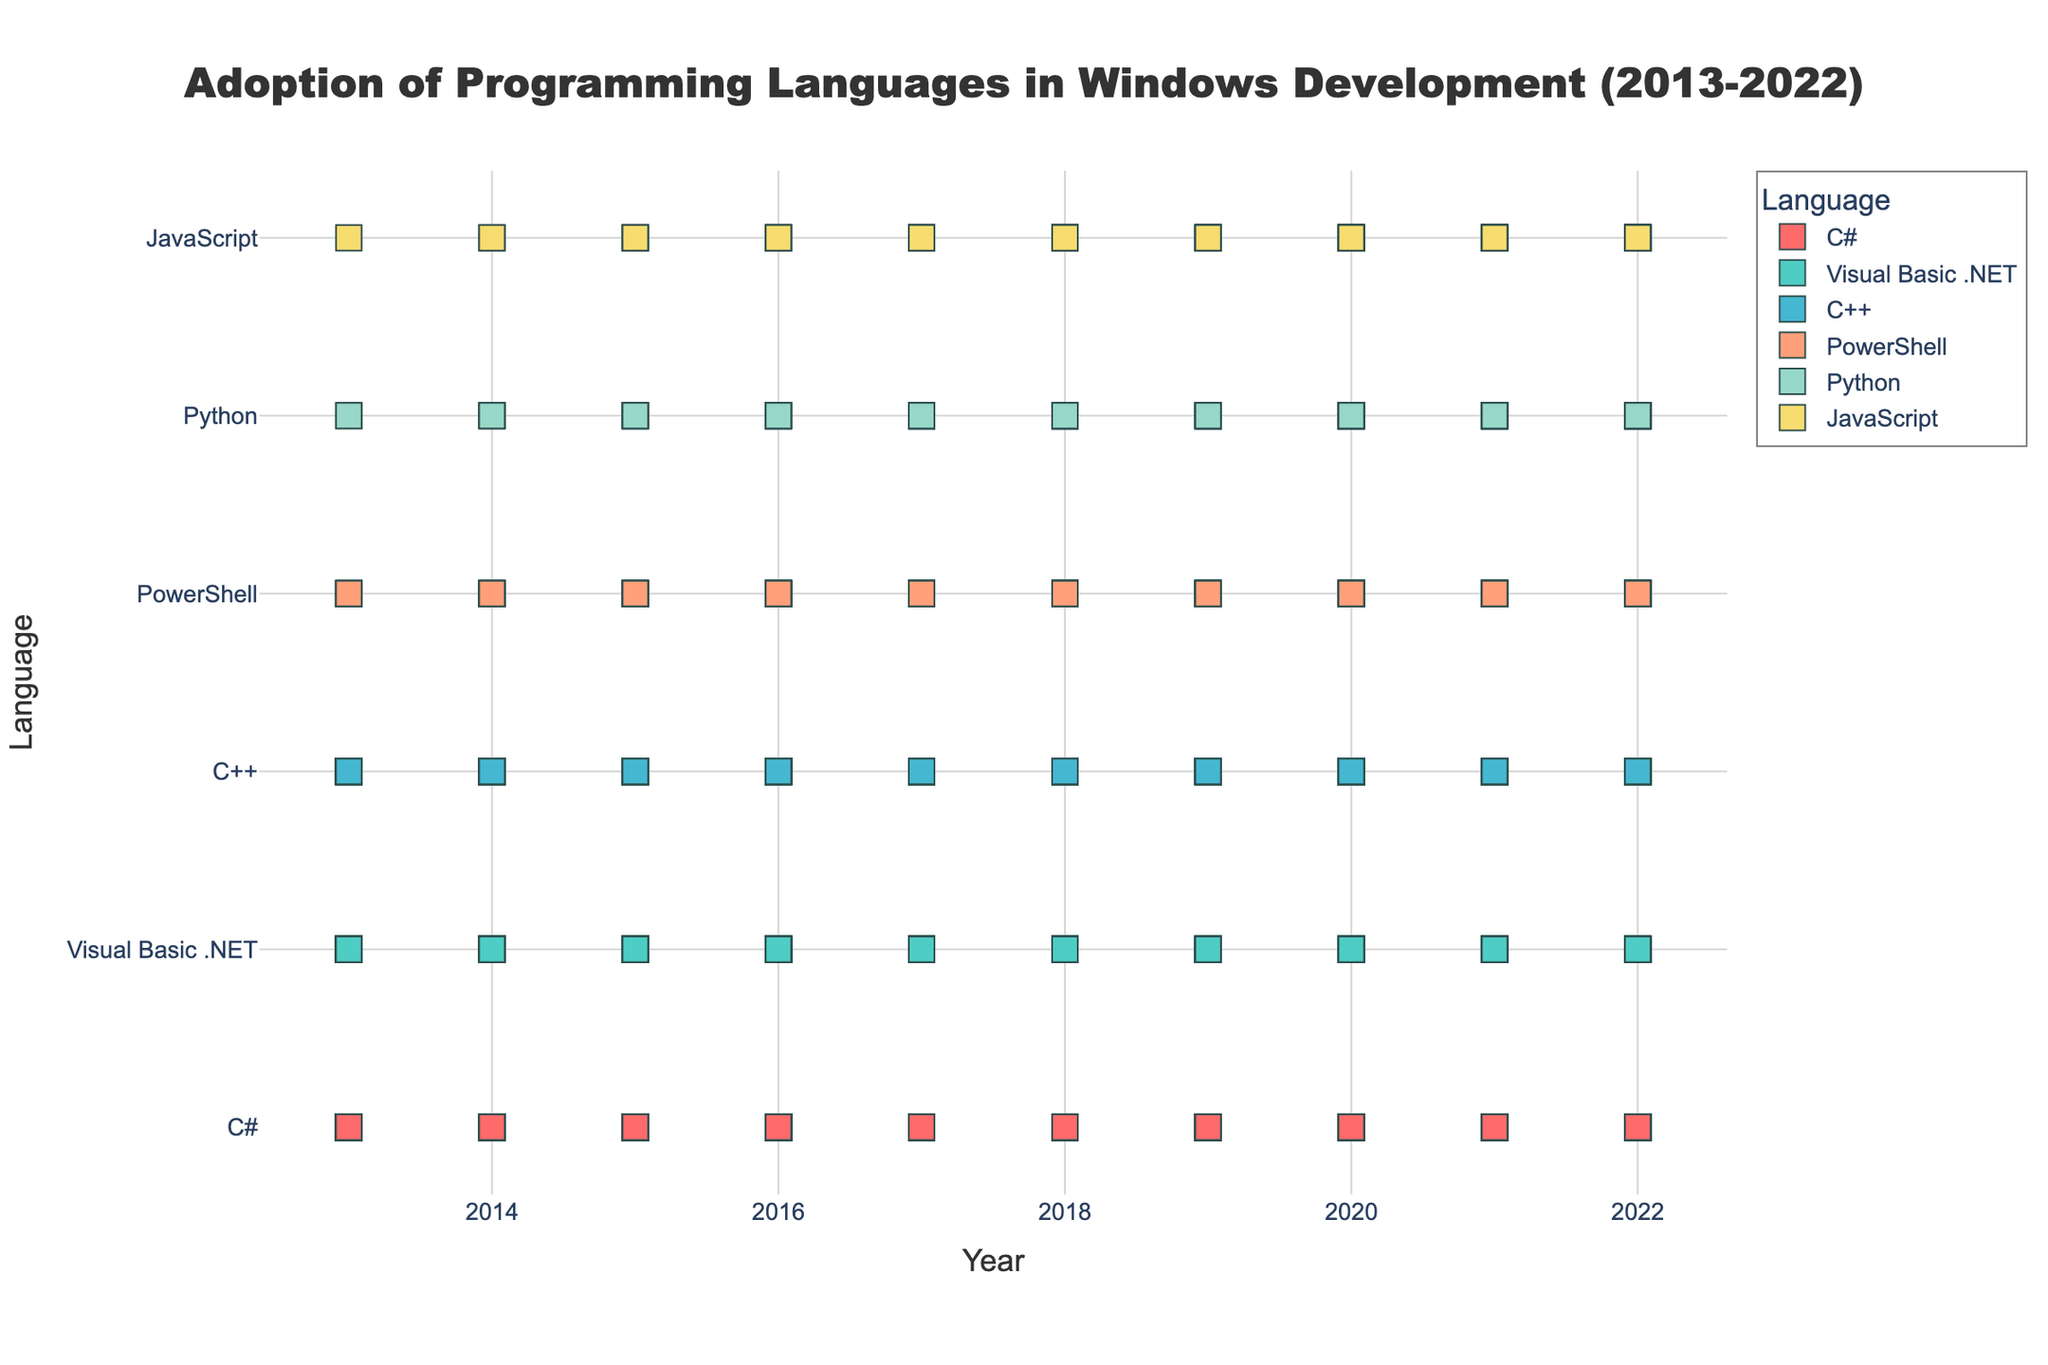what is the title of the figure? The title of the figure is located at the top and is often bold or larger than the other text. It helps provide context for the data being shown.
Answer: Adoption of Programming Languages in Windows Development (2013-2022) what programming language shows an increasing adoption rate from 2013 to 2022? To find this, look at the lines representing each language over the years. An increasing rate will show a consistently upward trend.
Answer: C#, C++, PowerShell, Python, JavaScript which language had the highest adoption rate in 2013? Check the y-axis position of each language's marker for the year 2013. The language with the highest y-value has the highest adoption rate.
Answer: C# what is the overall trend for Visual Basic .NET between 2013 and 2022? Observe the change in the y-axis position of the markers for Visual Basic .NET over the years. A downward trajectory indicates a decreasing trend.
Answer: Decreasing which languages had equal adoption rates in 2013? Compare the y-axis positions of the markers for each language in the year 2013. Any markers on the same y-level indicate equal adoption rates.
Answer: None How does the adoption rate for C++ in 2022 compare to that of PowerShell in the same year? Look at the y-axis positions of the markers for C++ and PowerShell in 2022. The marker higher on the y-axis has a higher adoption rate.
Answer: C++ has a higher rate than PowerShell what is the difference in the adoption rate for Python from 2013 to 2022? Subtract the 2013 adoption rate for Python from the 2022 adoption rate for Python. Use the y-axis values to determine these rates.
Answer: 9 which language has the steadiest growth rate? Identify the language whose markers show the most consistent upward spacing year over year without major fluctuations.
Answer: C# how do the adoption rates for JavaScript and Python compare in 2020? Compare the y-axis positions for JavaScript and Python in the year 2020. Check which marker is higher to determine which has the higher rate.
Answer: Equal what does the color of the markers indicate? The colors differentiate each programming language in the plot, making it easy to distinguish between them visually.
Answer: Different languages 